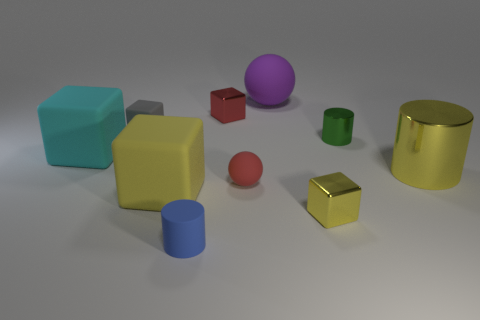Subtract all gray cubes. How many cubes are left? 4 Subtract all big yellow blocks. How many blocks are left? 4 Subtract all green cubes. Subtract all brown balls. How many cubes are left? 5 Subtract all cylinders. How many objects are left? 7 Add 3 small red metal objects. How many small red metal objects exist? 4 Subtract 2 yellow blocks. How many objects are left? 8 Subtract all blue cylinders. Subtract all blue things. How many objects are left? 8 Add 2 large yellow cylinders. How many large yellow cylinders are left? 3 